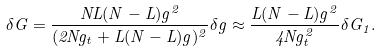Convert formula to latex. <formula><loc_0><loc_0><loc_500><loc_500>\delta G = \frac { N L ( N - L ) g ^ { 2 } } { ( 2 N g _ { t } + L ( N - L ) g ) ^ { 2 } } \delta g \approx \frac { L ( N - L ) g ^ { 2 } } { 4 N g _ { t } ^ { 2 } } \delta G _ { 1 } .</formula> 